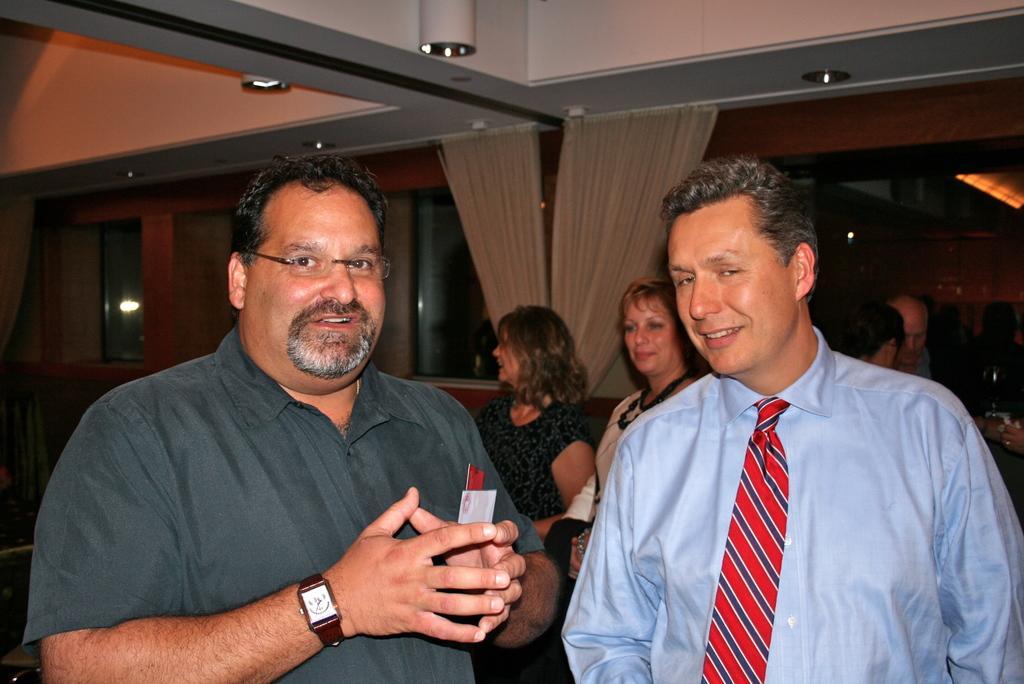How would you summarize this image in a sentence or two? In this image I can see 2 men standing in the front. There are other people at the back and there are curtains. 